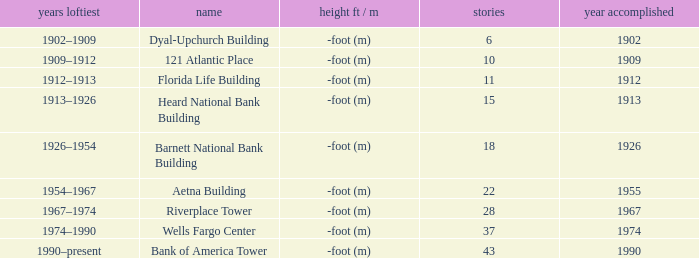What year was the building completed that has 10 floors? 1909.0. 